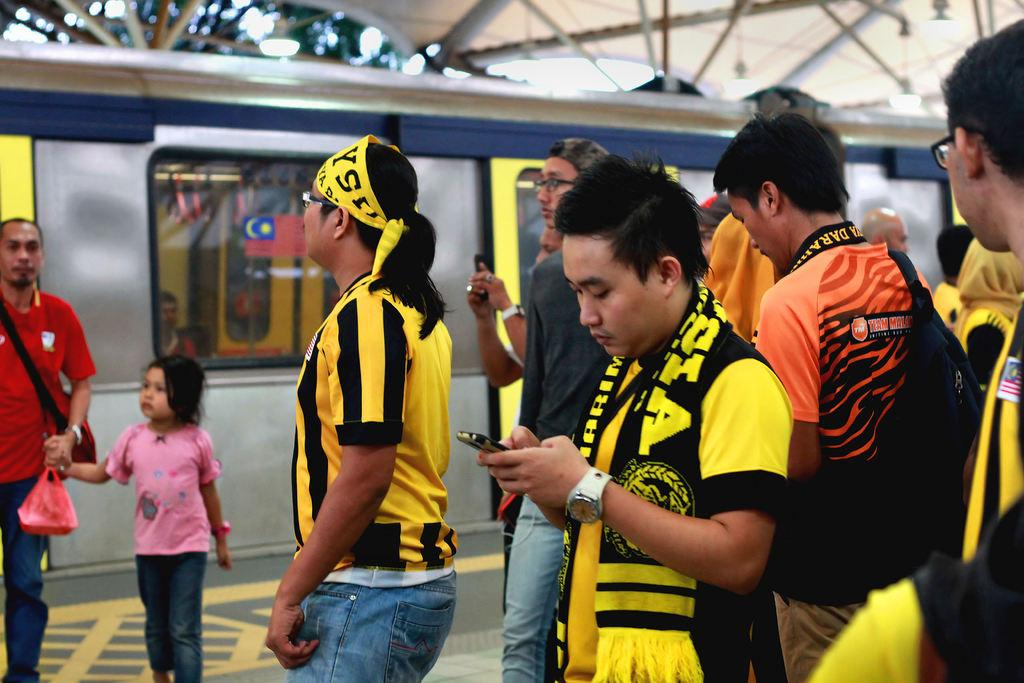How many people can be seen in the image? There are many people standing in the image. What can be seen in the background of the image? There is a train in the background of the image. What type of location is depicted in the image? The setting appears to be a railway station. What is present at the bottom of the image? There is a platform at the bottom of the image. What structure is visible at the top of the image? There is a shed at the top of the image. Can you see any rice being cooked in the image? There is no rice or cooking activity present in the image. Where is the nest of the ants located in the image? There are no ants or nests present in the image. 